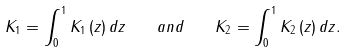Convert formula to latex. <formula><loc_0><loc_0><loc_500><loc_500>K _ { 1 } = \int _ { 0 } ^ { 1 } K _ { 1 } \left ( z \right ) d z \quad a n d \quad K _ { 2 } = \int _ { 0 } ^ { 1 } K _ { 2 } \left ( z \right ) d z .</formula> 